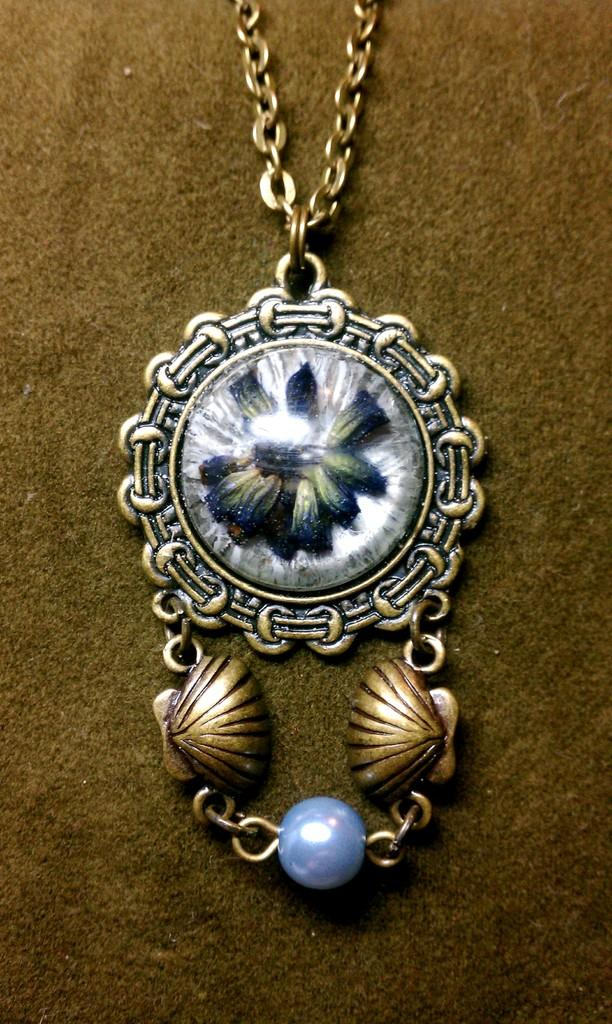What type of item is featured in the image? There is jewelry in the image. What is the color of the surface on which the jewelry is placed? The jewelry is on a brown surface. How many grains of rice can be seen in the image? There is no rice present in the image. What type of tree is growing near the jewelry in the image? There is no tree present in the image. 